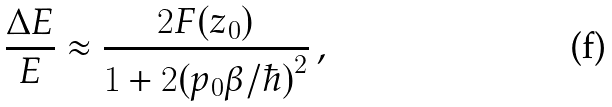Convert formula to latex. <formula><loc_0><loc_0><loc_500><loc_500>\frac { \Delta E } { E } \approx \frac { 2 F ( z _ { 0 } ) } { 1 + 2 ( p _ { 0 } \beta / \hbar { ) } ^ { 2 } } \, ,</formula> 